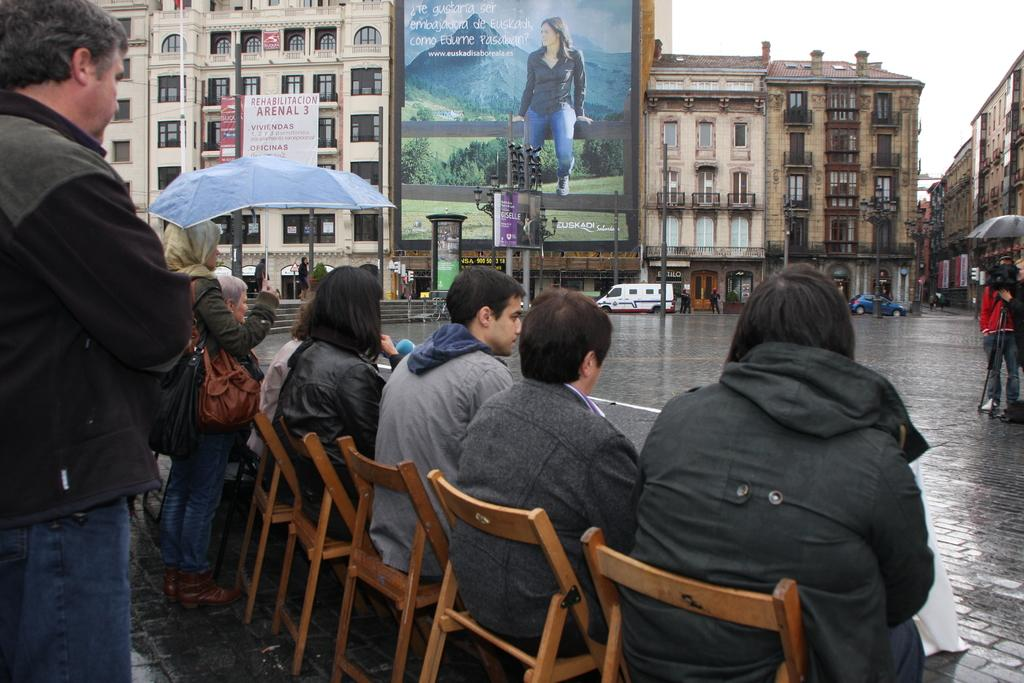What are the people in the image doing? The people in the image are sitting in chairs in a row. Can you describe the position of the man in the image? There is a man standing behind the row of chairs. What can be seen across from the row of chairs? There is a building opposite to the row of chairs. What is visible on the road in the image? There are cars and vehicles on the road. What type of square can be seen in the image? There is no square present in the image. What kind of teeth can be seen in the image? There are no teeth visible in the image. 